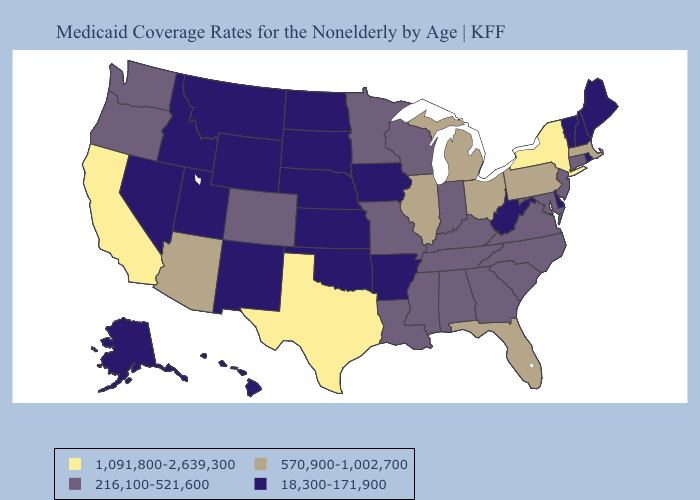Name the states that have a value in the range 570,900-1,002,700?
Be succinct. Arizona, Florida, Illinois, Massachusetts, Michigan, Ohio, Pennsylvania. Among the states that border Utah , does New Mexico have the highest value?
Concise answer only. No. Among the states that border Arizona , which have the highest value?
Quick response, please. California. What is the lowest value in the South?
Concise answer only. 18,300-171,900. What is the value of Iowa?
Short answer required. 18,300-171,900. What is the value of Idaho?
Concise answer only. 18,300-171,900. How many symbols are there in the legend?
Keep it brief. 4. Name the states that have a value in the range 570,900-1,002,700?
Answer briefly. Arizona, Florida, Illinois, Massachusetts, Michigan, Ohio, Pennsylvania. Name the states that have a value in the range 570,900-1,002,700?
Short answer required. Arizona, Florida, Illinois, Massachusetts, Michigan, Ohio, Pennsylvania. Name the states that have a value in the range 1,091,800-2,639,300?
Answer briefly. California, New York, Texas. Among the states that border Vermont , which have the highest value?
Short answer required. New York. How many symbols are there in the legend?
Short answer required. 4. Among the states that border Wisconsin , does Michigan have the lowest value?
Concise answer only. No. Does Ohio have the highest value in the MidWest?
Answer briefly. Yes. 